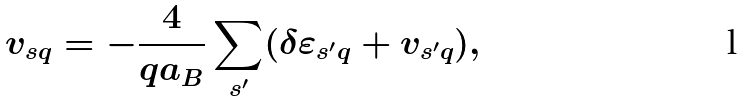<formula> <loc_0><loc_0><loc_500><loc_500>v _ { s { q } } = - \frac { 4 } { q a _ { B } } \sum _ { s ^ { \prime } } ( \delta \varepsilon _ { s ^ { \prime } { q } } + v _ { s ^ { \prime } { q } } ) ,</formula> 